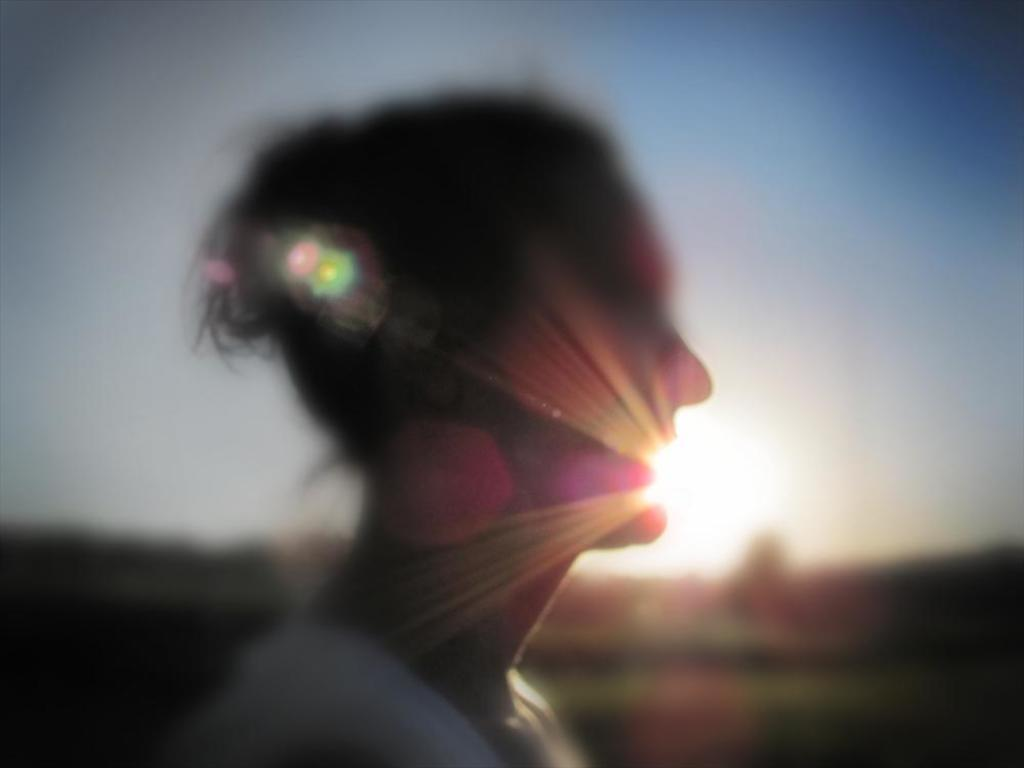What is the main subject of the image? There is a blurred person in the image. What can be observed about the background of the image? The background of the image is blurred. What level of experience does the beginner have in the image? There is no indication of a beginner or any experience level in the image, as it only features a blurred person and a blurred background. 